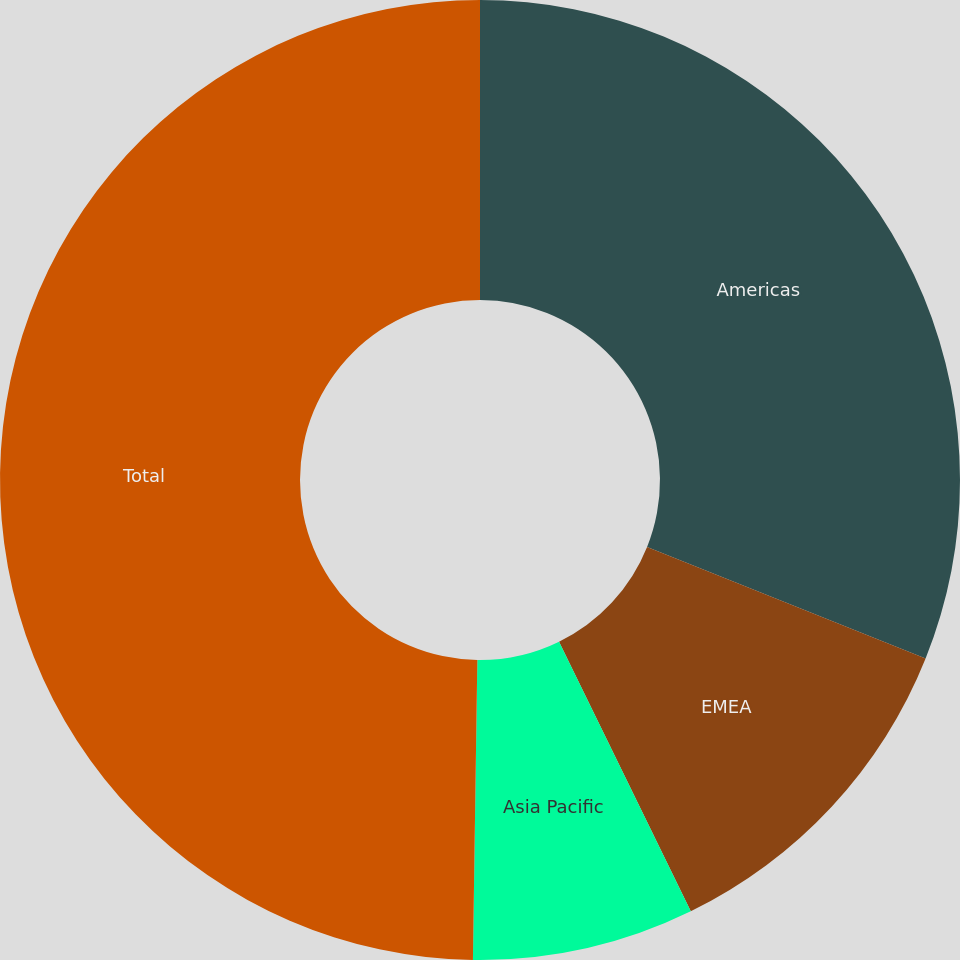Convert chart. <chart><loc_0><loc_0><loc_500><loc_500><pie_chart><fcel>Americas<fcel>EMEA<fcel>Asia Pacific<fcel>Total<nl><fcel>31.06%<fcel>11.7%<fcel>7.47%<fcel>49.76%<nl></chart> 